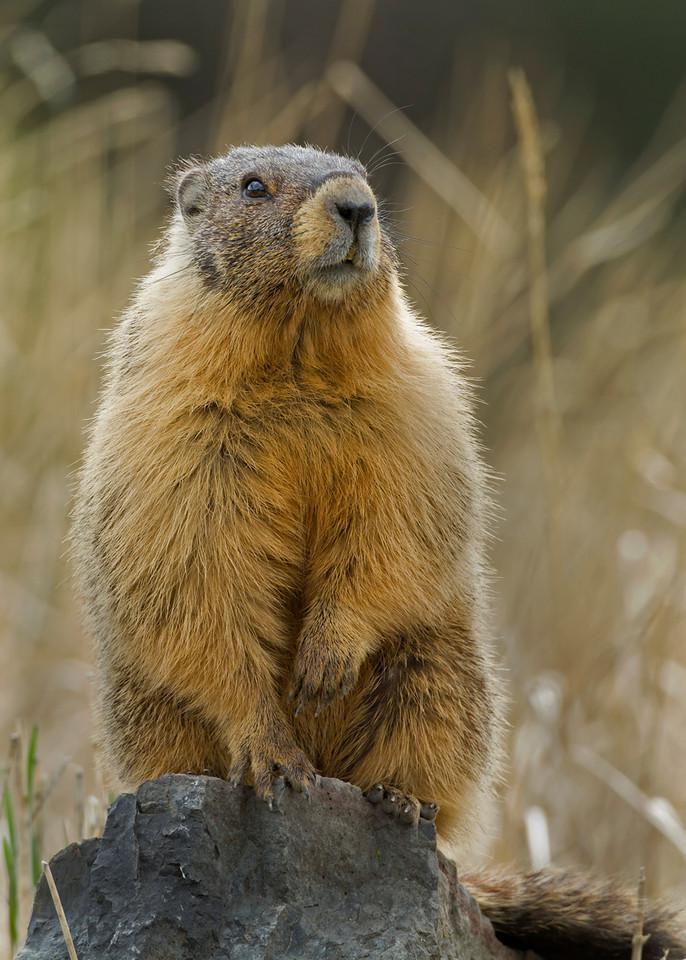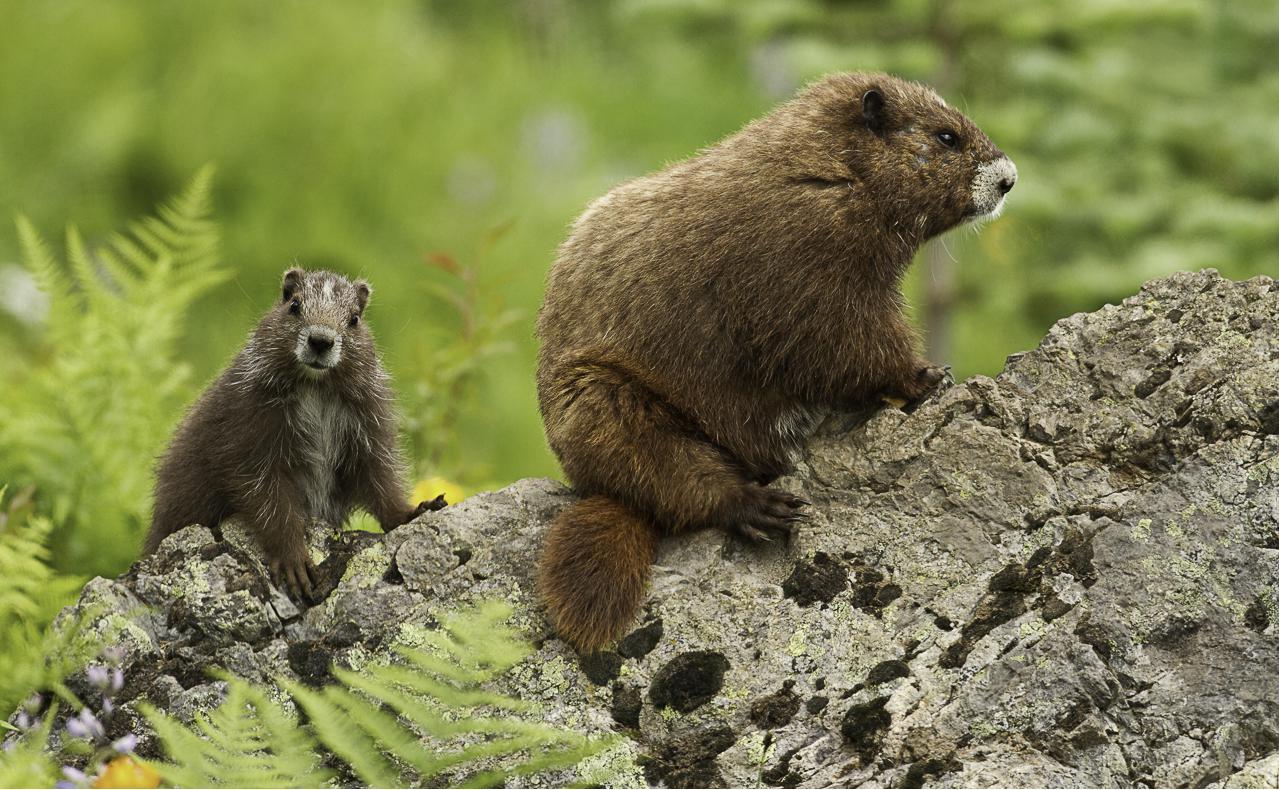The first image is the image on the left, the second image is the image on the right. Given the left and right images, does the statement "Each image contains a single marmot, and the right image features a marmot standing and facing leftward." hold true? Answer yes or no. No. The first image is the image on the left, the second image is the image on the right. For the images shown, is this caption "There are exactly 2 marmots and one of them is standing on its hind legs." true? Answer yes or no. No. 